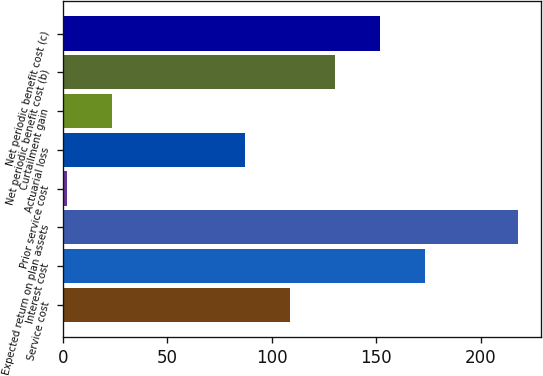Convert chart to OTSL. <chart><loc_0><loc_0><loc_500><loc_500><bar_chart><fcel>Service cost<fcel>Interest cost<fcel>Expected return on plan assets<fcel>Prior service cost<fcel>Actuarial loss<fcel>Curtailment gain<fcel>Net periodic benefit cost (b)<fcel>Net periodic benefit cost (c)<nl><fcel>108.6<fcel>173.4<fcel>218<fcel>2<fcel>87<fcel>23.6<fcel>130.2<fcel>151.8<nl></chart> 